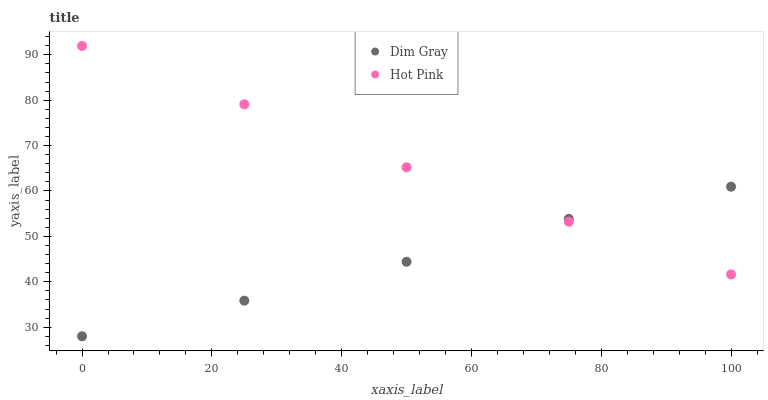Does Dim Gray have the minimum area under the curve?
Answer yes or no. Yes. Does Hot Pink have the maximum area under the curve?
Answer yes or no. Yes. Does Hot Pink have the minimum area under the curve?
Answer yes or no. No. Is Hot Pink the smoothest?
Answer yes or no. Yes. Is Dim Gray the roughest?
Answer yes or no. Yes. Is Hot Pink the roughest?
Answer yes or no. No. Does Dim Gray have the lowest value?
Answer yes or no. Yes. Does Hot Pink have the lowest value?
Answer yes or no. No. Does Hot Pink have the highest value?
Answer yes or no. Yes. Does Dim Gray intersect Hot Pink?
Answer yes or no. Yes. Is Dim Gray less than Hot Pink?
Answer yes or no. No. Is Dim Gray greater than Hot Pink?
Answer yes or no. No. 